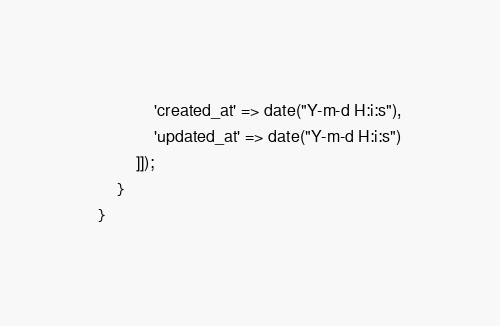<code> <loc_0><loc_0><loc_500><loc_500><_PHP_>			'created_at' => date("Y-m-d H:i:s"),
			'updated_at' => date("Y-m-d H:i:s")
        ]]);
    }
}
</code> 